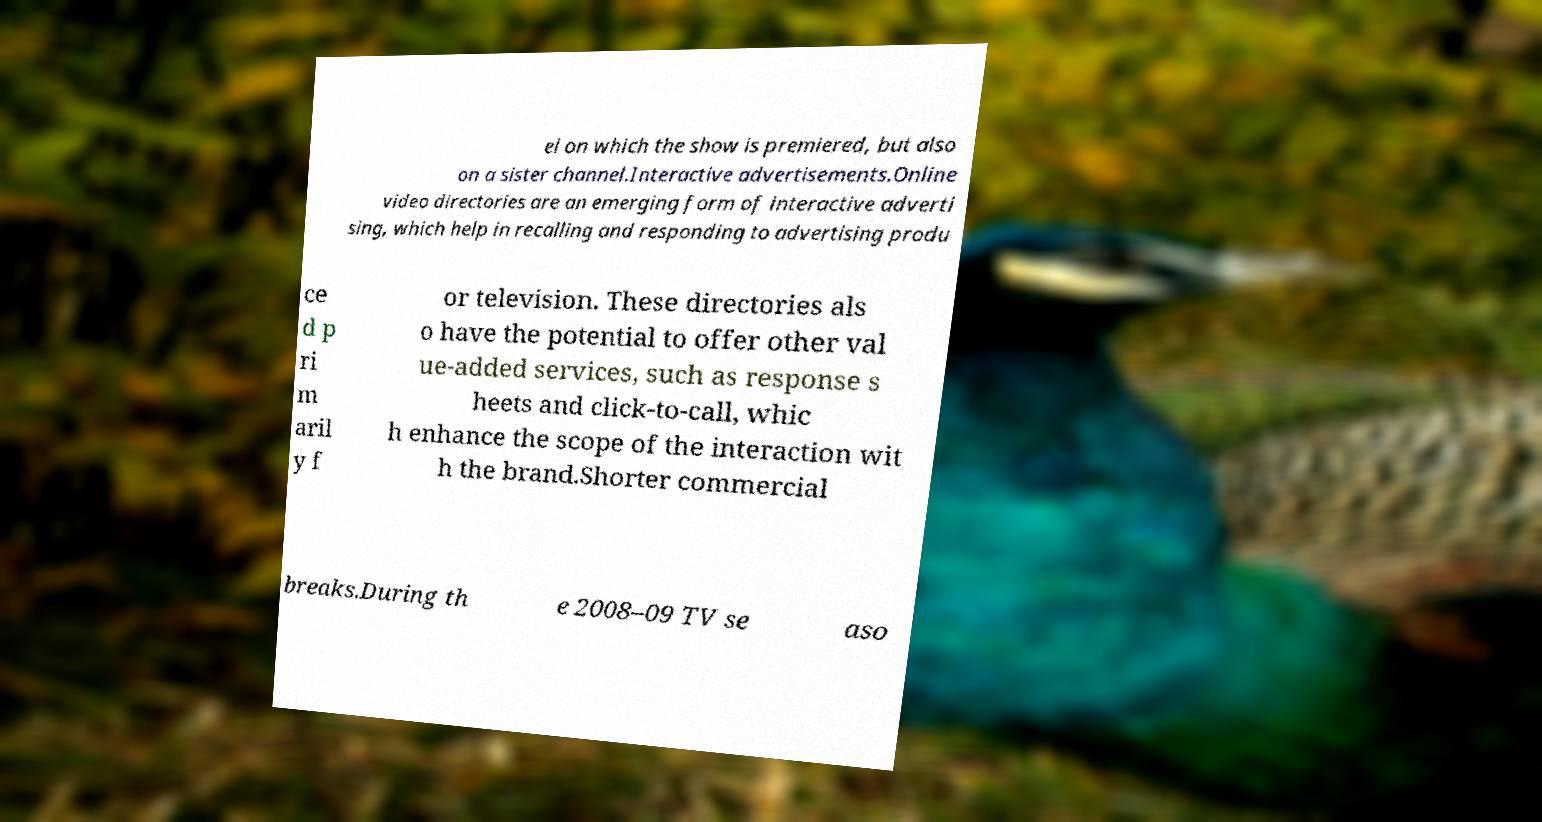There's text embedded in this image that I need extracted. Can you transcribe it verbatim? el on which the show is premiered, but also on a sister channel.Interactive advertisements.Online video directories are an emerging form of interactive adverti sing, which help in recalling and responding to advertising produ ce d p ri m aril y f or television. These directories als o have the potential to offer other val ue-added services, such as response s heets and click-to-call, whic h enhance the scope of the interaction wit h the brand.Shorter commercial breaks.During th e 2008–09 TV se aso 